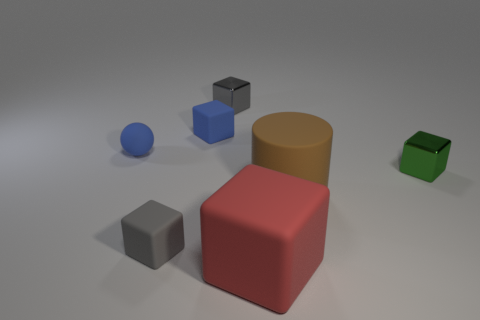Subtract all red matte blocks. How many blocks are left? 4 Subtract 1 cubes. How many cubes are left? 4 Add 1 blue cubes. How many objects exist? 8 Subtract all green blocks. How many blocks are left? 4 Subtract all blue blocks. Subtract all red cylinders. How many blocks are left? 4 Subtract all cubes. How many objects are left? 2 Add 2 small blue rubber blocks. How many small blue rubber blocks are left? 3 Add 4 big blocks. How many big blocks exist? 5 Subtract 1 blue spheres. How many objects are left? 6 Subtract all tiny matte things. Subtract all tiny gray objects. How many objects are left? 2 